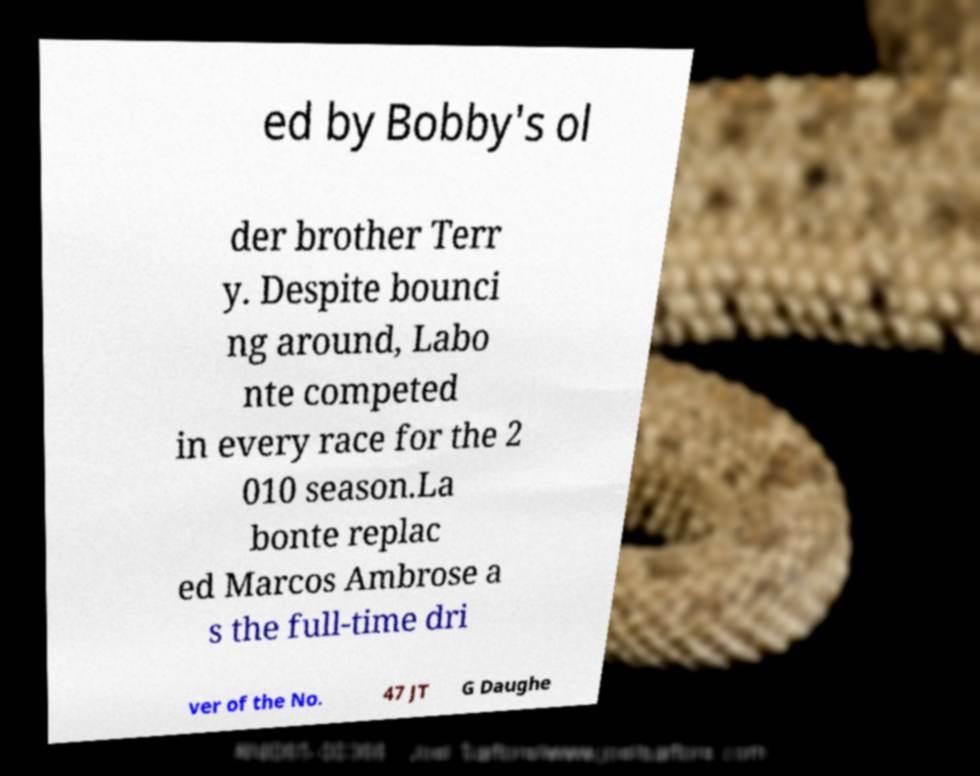Can you accurately transcribe the text from the provided image for me? ed by Bobby's ol der brother Terr y. Despite bounci ng around, Labo nte competed in every race for the 2 010 season.La bonte replac ed Marcos Ambrose a s the full-time dri ver of the No. 47 JT G Daughe 